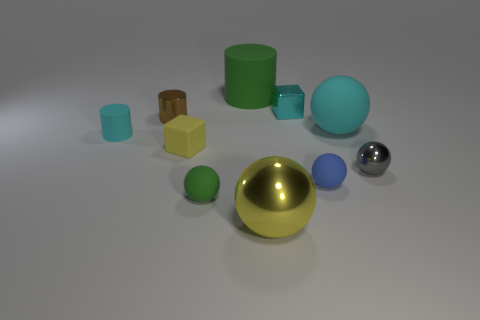Subtract 3 spheres. How many spheres are left? 2 Subtract all yellow spheres. Subtract all cyan blocks. How many spheres are left? 4 Subtract all cubes. How many objects are left? 8 Add 4 big purple matte cylinders. How many big purple matte cylinders exist? 4 Subtract 1 cyan balls. How many objects are left? 9 Subtract all big matte cylinders. Subtract all yellow metal balls. How many objects are left? 8 Add 5 large cyan rubber things. How many large cyan rubber things are left? 6 